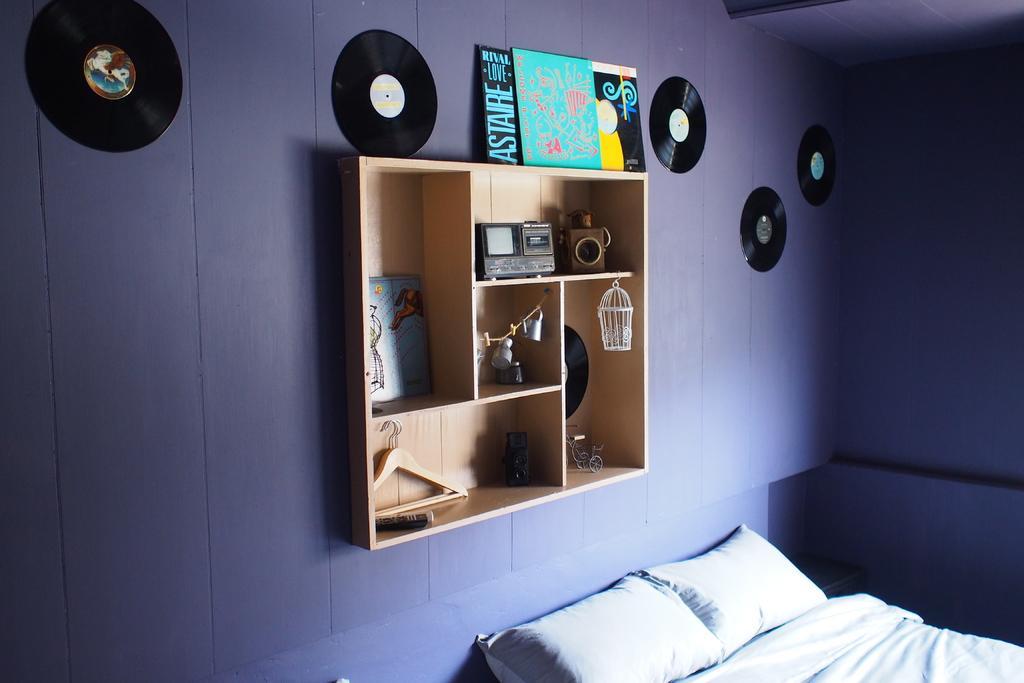Could you give a brief overview of what you see in this image? In this picture I can observe a shelf. There are some hangers and a radio placed in this shelf. I can observe a photo frame placed on this shelf. On the right side there is a bed on which I can observe two pillows. In the background I can observe a wall which is in purple color. 